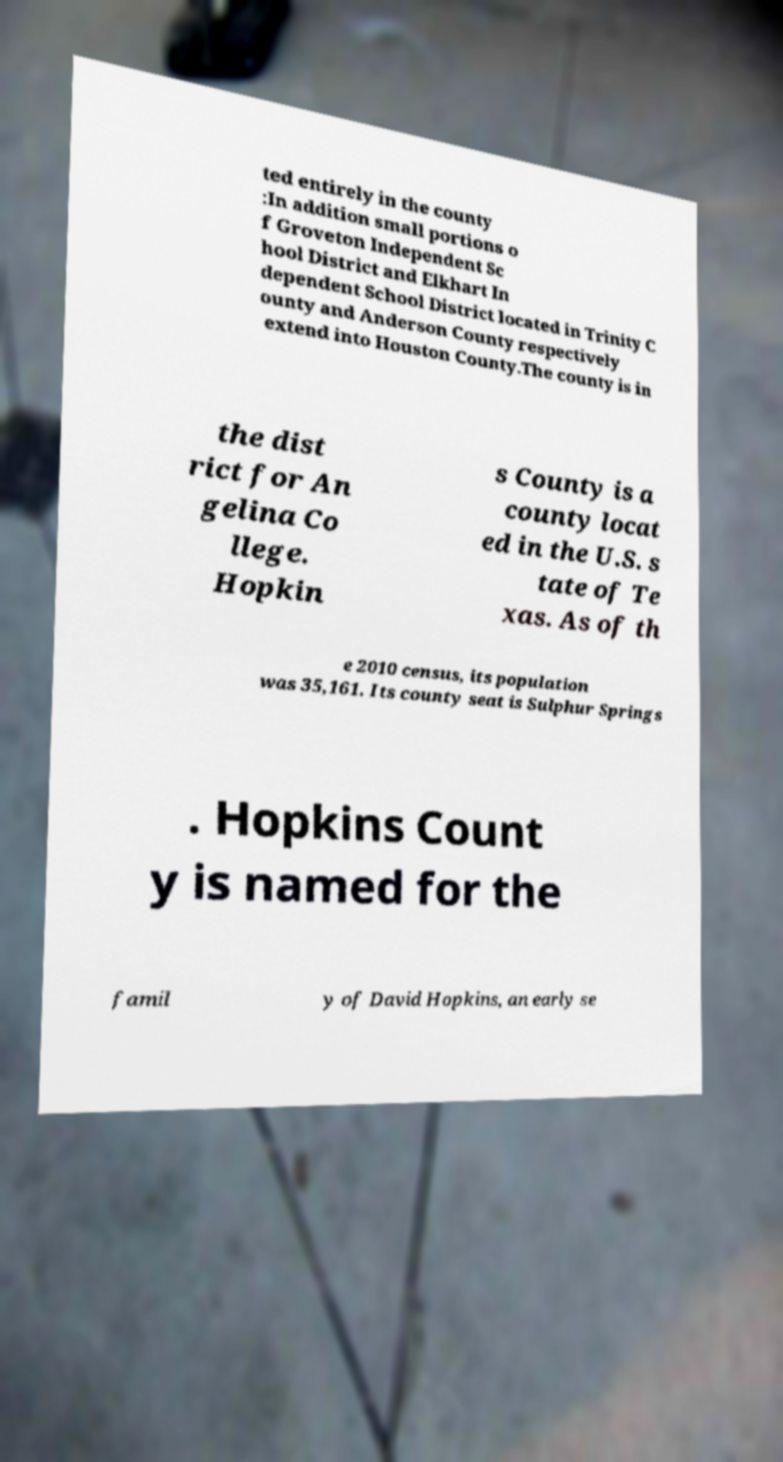There's text embedded in this image that I need extracted. Can you transcribe it verbatim? ted entirely in the county :In addition small portions o f Groveton Independent Sc hool District and Elkhart In dependent School District located in Trinity C ounty and Anderson County respectively extend into Houston County.The county is in the dist rict for An gelina Co llege. Hopkin s County is a county locat ed in the U.S. s tate of Te xas. As of th e 2010 census, its population was 35,161. Its county seat is Sulphur Springs . Hopkins Count y is named for the famil y of David Hopkins, an early se 